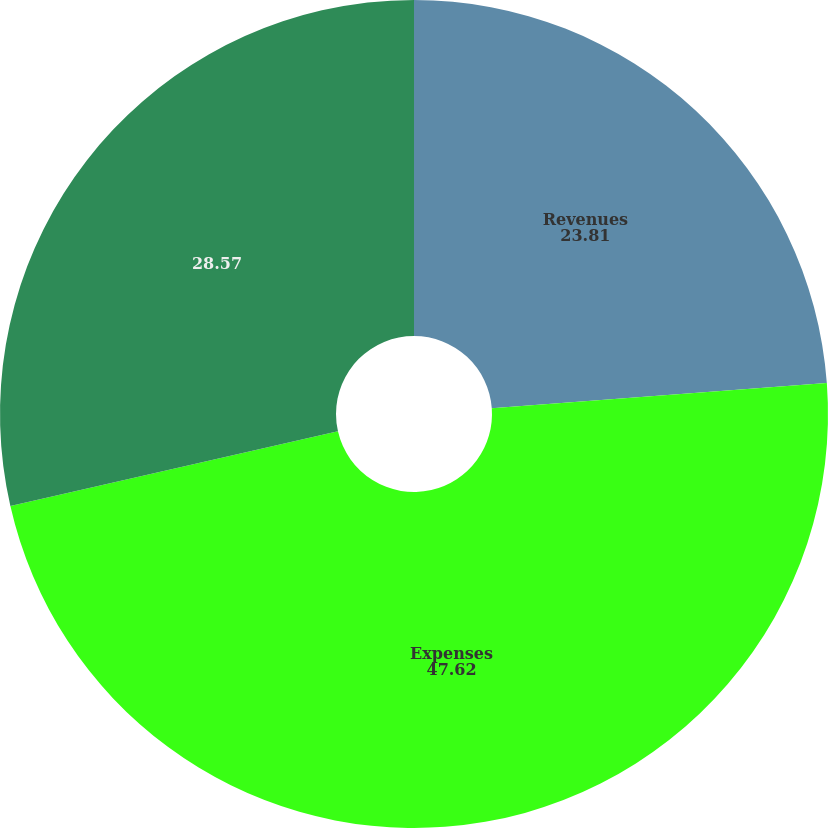<chart> <loc_0><loc_0><loc_500><loc_500><pie_chart><fcel>Revenues<fcel>Expenses<fcel>Unnamed: 2<nl><fcel>23.81%<fcel>47.62%<fcel>28.57%<nl></chart> 